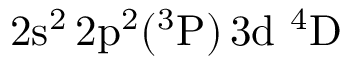<formula> <loc_0><loc_0><loc_500><loc_500>2 s ^ { 2 } \, 2 p ^ { 2 } ( ^ { 3 } P ) \, 3 d ^ { 4 } D</formula> 